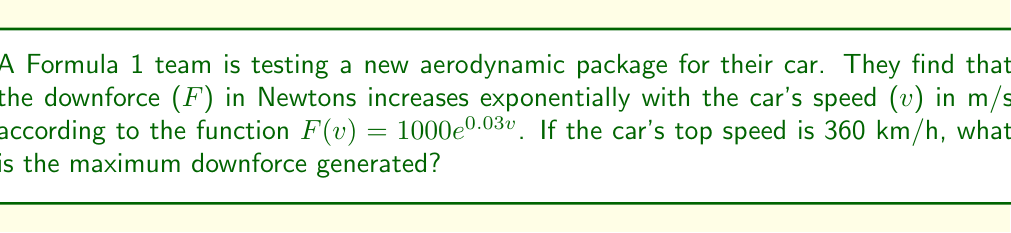Help me with this question. 1) First, we need to convert the top speed from km/h to m/s:
   $360 \text{ km/h} = 360 \times \frac{1000 \text{ m}}{3600 \text{ s}} = 100 \text{ m/s}$

2) Now we can substitute this speed into our function:
   $F(100) = 1000e^{0.03(100)}$

3) Let's evaluate the exponent:
   $0.03 \times 100 = 3$

4) Our equation is now:
   $F(100) = 1000e^3$

5) Using a calculator or exponential table:
   $e^3 \approx 20.0855$

6) Multiply this by 1000:
   $F(100) = 1000 \times 20.0855 = 20085.5 \text{ N}$

7) Round to the nearest whole number:
   $F(100) \approx 20086 \text{ N}$
Answer: 20086 N 